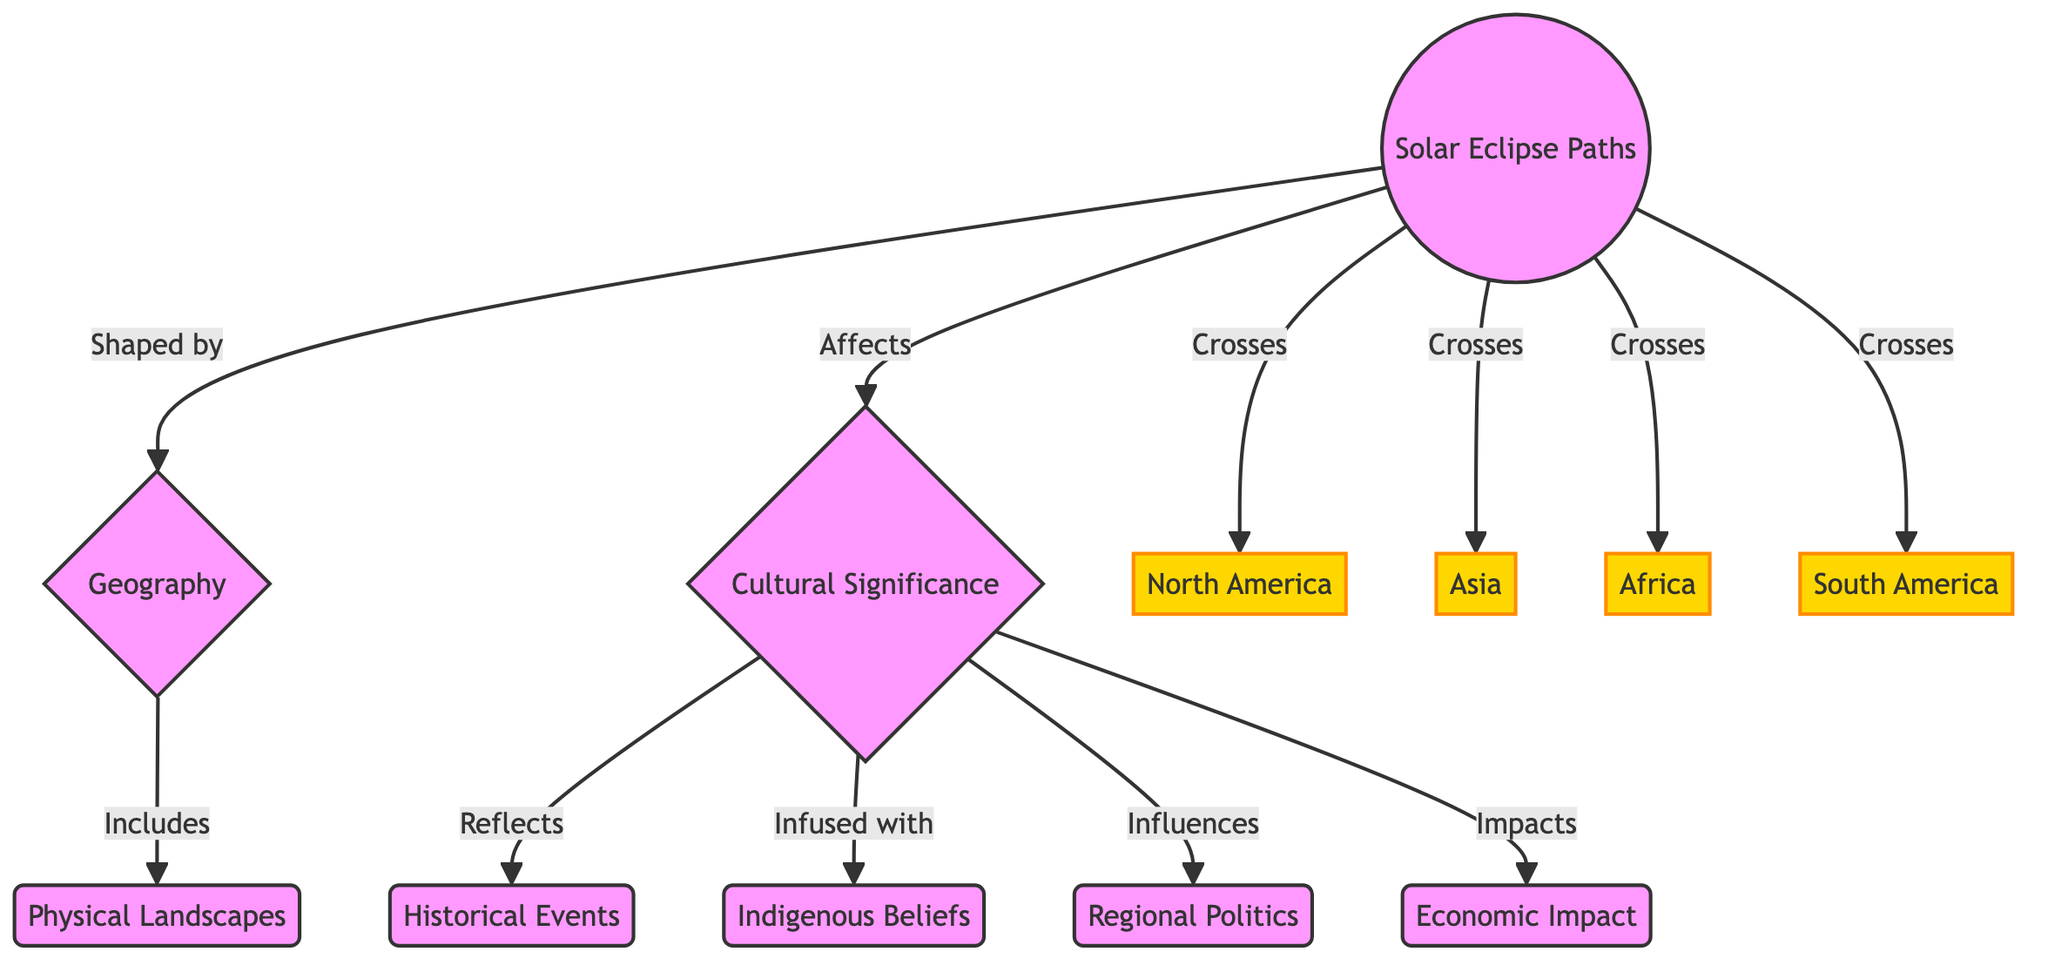What do solar eclipse paths influence? The diagram indicates that solar eclipse paths affect cultural significance. This is shown by the directed arrow from "Solar Eclipse Paths" to "Cultural Significance."
Answer: Cultural Significance Which regions are crossed by solar eclipse paths? The diagram lists North America, Asia, Africa, and South America as the regions crossed by solar eclipse paths. These regions are directly linked to the "Solar Eclipse Paths" node.
Answer: North America, Asia, Africa, South America What is included in geography according to the diagram? The diagram specifies that physical landscapes are included in geography. This relationship is represented by the arrow linking "Geography" to "Physical Landscapes."
Answer: Physical Landscapes How does cultural significance reflect historical events? The arrow from "Cultural Significance" to "Historical Events" indicates that cultural significance reflects historical events. This shows a direct relationship where cultural significance incorporates aspects of history.
Answer: Historical Events What does cultural significance influence? The diagram illustrates multiple influences of cultural significance, including regional politics. This is depicted by the directed arrow from "Cultural Significance" to "Regional Politics."
Answer: Regional Politics What are the aspects infused within cultural significance? According to the diagram, indigenous beliefs are infused within cultural significance. This is shown by the connection from "Cultural Significance" to "Indigenous Beliefs."
Answer: Indigenous Beliefs Why are cultural significance and physical landscapes linked in the diagram? The diagram establishes that cultural significance and geography are interconnected. Geography includes physical landscapes, which can influence the development of cultural significance, suggesting a relationship between the two.
Answer: Cultural Significance influences Geography How many regions are presented in the diagram? The diagram lists four regions: North America, Asia, Africa, and South America, indicating that there are a total of four regions addressed.
Answer: 4 What is the impact of cultural significance as indicated in the diagram? The diagram indicates that cultural significance has an impact on economic impact. This is shown by the arrow connecting "Cultural Significance" to "Economic Impact."
Answer: Economic Impact 